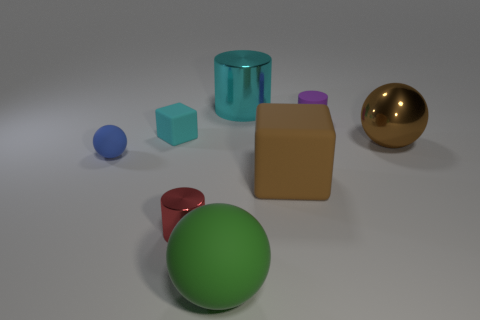There is a small rubber object that is on the left side of the cyan matte object; does it have the same color as the cylinder that is right of the large cylinder?
Offer a very short reply. No. Are there fewer metallic cylinders that are behind the red metallic cylinder than tiny metallic things in front of the green object?
Provide a short and direct response. No. What is the shape of the thing behind the tiny matte cylinder?
Your response must be concise. Cylinder. What is the material of the object that is the same color as the big metallic sphere?
Make the answer very short. Rubber. How many other things are the same material as the large green ball?
Offer a terse response. 4. There is a small purple thing; is it the same shape as the cyan object that is on the left side of the big cyan shiny cylinder?
Keep it short and to the point. No. The green thing that is made of the same material as the tiny blue object is what shape?
Your answer should be very brief. Sphere. Is the number of blue rubber objects that are to the right of the small blue matte sphere greater than the number of large metal cylinders right of the shiny ball?
Your answer should be very brief. No. What number of objects are big metallic cubes or big balls?
Give a very brief answer. 2. What number of other things are there of the same color as the tiny block?
Offer a terse response. 1. 